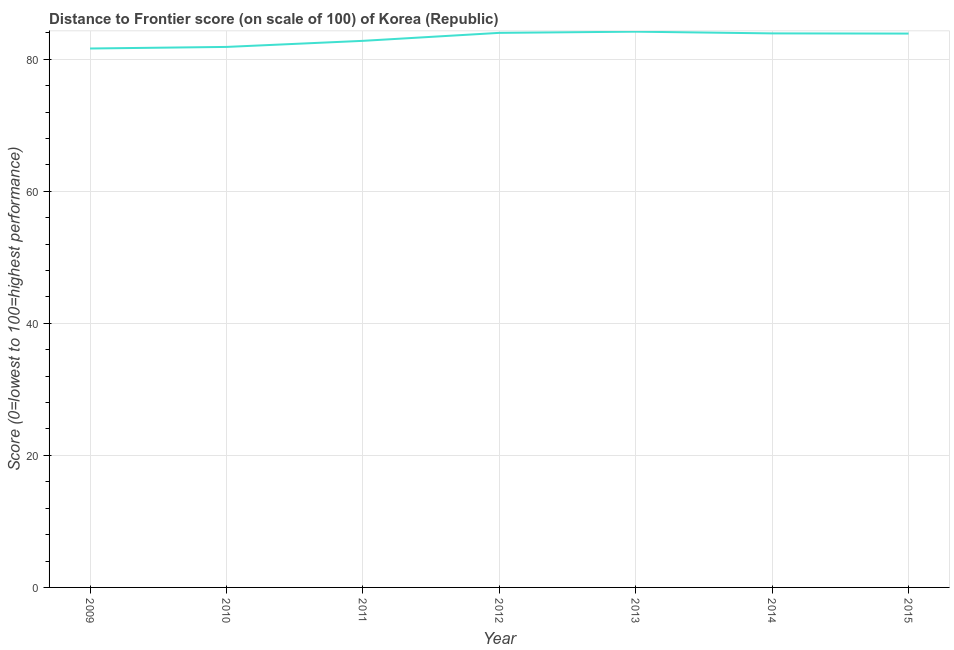What is the distance to frontier score in 2009?
Provide a succinct answer. 81.62. Across all years, what is the maximum distance to frontier score?
Offer a very short reply. 84.17. Across all years, what is the minimum distance to frontier score?
Give a very brief answer. 81.62. In which year was the distance to frontier score maximum?
Keep it short and to the point. 2013. In which year was the distance to frontier score minimum?
Your answer should be compact. 2009. What is the sum of the distance to frontier score?
Your answer should be very brief. 582.21. What is the difference between the distance to frontier score in 2009 and 2015?
Your response must be concise. -2.26. What is the average distance to frontier score per year?
Give a very brief answer. 83.17. What is the median distance to frontier score?
Your answer should be compact. 83.88. What is the ratio of the distance to frontier score in 2013 to that in 2015?
Make the answer very short. 1. Is the distance to frontier score in 2009 less than that in 2015?
Your answer should be very brief. Yes. What is the difference between the highest and the second highest distance to frontier score?
Provide a short and direct response. 0.18. Is the sum of the distance to frontier score in 2009 and 2013 greater than the maximum distance to frontier score across all years?
Keep it short and to the point. Yes. What is the difference between the highest and the lowest distance to frontier score?
Your answer should be very brief. 2.55. How many lines are there?
Provide a succinct answer. 1. What is the difference between two consecutive major ticks on the Y-axis?
Your answer should be very brief. 20. What is the title of the graph?
Keep it short and to the point. Distance to Frontier score (on scale of 100) of Korea (Republic). What is the label or title of the X-axis?
Your answer should be compact. Year. What is the label or title of the Y-axis?
Give a very brief answer. Score (0=lowest to 100=highest performance). What is the Score (0=lowest to 100=highest performance) in 2009?
Make the answer very short. 81.62. What is the Score (0=lowest to 100=highest performance) of 2010?
Offer a terse response. 81.86. What is the Score (0=lowest to 100=highest performance) in 2011?
Provide a short and direct response. 82.78. What is the Score (0=lowest to 100=highest performance) of 2012?
Offer a very short reply. 83.99. What is the Score (0=lowest to 100=highest performance) of 2013?
Ensure brevity in your answer.  84.17. What is the Score (0=lowest to 100=highest performance) in 2014?
Provide a short and direct response. 83.91. What is the Score (0=lowest to 100=highest performance) in 2015?
Provide a succinct answer. 83.88. What is the difference between the Score (0=lowest to 100=highest performance) in 2009 and 2010?
Keep it short and to the point. -0.24. What is the difference between the Score (0=lowest to 100=highest performance) in 2009 and 2011?
Provide a short and direct response. -1.16. What is the difference between the Score (0=lowest to 100=highest performance) in 2009 and 2012?
Offer a very short reply. -2.37. What is the difference between the Score (0=lowest to 100=highest performance) in 2009 and 2013?
Keep it short and to the point. -2.55. What is the difference between the Score (0=lowest to 100=highest performance) in 2009 and 2014?
Give a very brief answer. -2.29. What is the difference between the Score (0=lowest to 100=highest performance) in 2009 and 2015?
Ensure brevity in your answer.  -2.26. What is the difference between the Score (0=lowest to 100=highest performance) in 2010 and 2011?
Ensure brevity in your answer.  -0.92. What is the difference between the Score (0=lowest to 100=highest performance) in 2010 and 2012?
Ensure brevity in your answer.  -2.13. What is the difference between the Score (0=lowest to 100=highest performance) in 2010 and 2013?
Provide a succinct answer. -2.31. What is the difference between the Score (0=lowest to 100=highest performance) in 2010 and 2014?
Give a very brief answer. -2.05. What is the difference between the Score (0=lowest to 100=highest performance) in 2010 and 2015?
Provide a short and direct response. -2.02. What is the difference between the Score (0=lowest to 100=highest performance) in 2011 and 2012?
Provide a short and direct response. -1.21. What is the difference between the Score (0=lowest to 100=highest performance) in 2011 and 2013?
Make the answer very short. -1.39. What is the difference between the Score (0=lowest to 100=highest performance) in 2011 and 2014?
Offer a very short reply. -1.13. What is the difference between the Score (0=lowest to 100=highest performance) in 2012 and 2013?
Provide a succinct answer. -0.18. What is the difference between the Score (0=lowest to 100=highest performance) in 2012 and 2015?
Offer a very short reply. 0.11. What is the difference between the Score (0=lowest to 100=highest performance) in 2013 and 2014?
Offer a terse response. 0.26. What is the difference between the Score (0=lowest to 100=highest performance) in 2013 and 2015?
Offer a terse response. 0.29. What is the difference between the Score (0=lowest to 100=highest performance) in 2014 and 2015?
Your answer should be compact. 0.03. What is the ratio of the Score (0=lowest to 100=highest performance) in 2009 to that in 2011?
Provide a short and direct response. 0.99. What is the ratio of the Score (0=lowest to 100=highest performance) in 2009 to that in 2013?
Keep it short and to the point. 0.97. What is the ratio of the Score (0=lowest to 100=highest performance) in 2009 to that in 2014?
Provide a short and direct response. 0.97. What is the ratio of the Score (0=lowest to 100=highest performance) in 2009 to that in 2015?
Give a very brief answer. 0.97. What is the ratio of the Score (0=lowest to 100=highest performance) in 2010 to that in 2012?
Ensure brevity in your answer.  0.97. What is the ratio of the Score (0=lowest to 100=highest performance) in 2010 to that in 2014?
Offer a terse response. 0.98. What is the ratio of the Score (0=lowest to 100=highest performance) in 2010 to that in 2015?
Give a very brief answer. 0.98. What is the ratio of the Score (0=lowest to 100=highest performance) in 2011 to that in 2014?
Provide a succinct answer. 0.99. What is the ratio of the Score (0=lowest to 100=highest performance) in 2011 to that in 2015?
Your response must be concise. 0.99. What is the ratio of the Score (0=lowest to 100=highest performance) in 2012 to that in 2013?
Ensure brevity in your answer.  1. What is the ratio of the Score (0=lowest to 100=highest performance) in 2013 to that in 2015?
Your answer should be compact. 1. What is the ratio of the Score (0=lowest to 100=highest performance) in 2014 to that in 2015?
Your answer should be very brief. 1. 